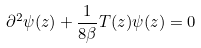<formula> <loc_0><loc_0><loc_500><loc_500>\partial ^ { 2 } \psi ( z ) + \frac { 1 } { 8 \beta } T ( z ) \psi ( z ) = 0</formula> 